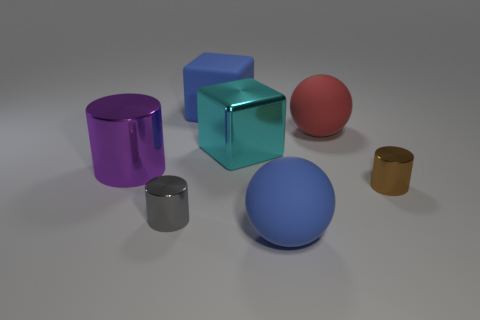There is a matte thing in front of the large matte sphere behind the small metallic thing right of the tiny gray metal cylinder; what shape is it?
Your response must be concise. Sphere. There is a blue object to the left of the large ball in front of the large cyan metal thing; what is its material?
Give a very brief answer. Rubber. What is the shape of the brown thing that is made of the same material as the purple object?
Your answer should be compact. Cylinder. There is a large purple metallic cylinder; how many big blue rubber things are behind it?
Your answer should be very brief. 1. Are there any cyan metallic cylinders?
Offer a terse response. No. What is the color of the tiny shiny cylinder right of the blue object behind the metal cylinder that is behind the brown thing?
Ensure brevity in your answer.  Brown. Are there any gray shiny cylinders that are to the right of the tiny metal cylinder that is right of the large red object?
Ensure brevity in your answer.  No. There is a big object in front of the gray cylinder; is its color the same as the large rubber thing that is behind the red matte ball?
Provide a short and direct response. Yes. What number of brown metallic things have the same size as the red sphere?
Offer a very short reply. 0. Is the size of the sphere in front of the purple cylinder the same as the large purple shiny thing?
Keep it short and to the point. Yes. 